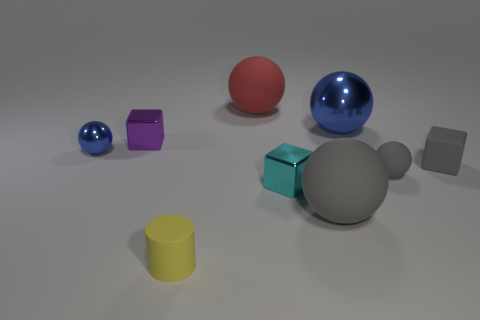What is the size of the blue shiny object that is on the right side of the gray rubber ball to the left of the tiny rubber sphere?
Your response must be concise. Large. What number of cubes are tiny metal objects or big cyan matte objects?
Provide a succinct answer. 2. What is the color of the other matte ball that is the same size as the red sphere?
Offer a very short reply. Gray. There is a gray rubber thing that is to the left of the metallic sphere on the right side of the small yellow object; what is its shape?
Keep it short and to the point. Sphere. There is a shiny thing in front of the matte block; is its size the same as the small blue object?
Provide a succinct answer. Yes. What number of other objects are there of the same material as the red sphere?
Provide a succinct answer. 4. How many gray objects are tiny matte spheres or metallic things?
Offer a terse response. 1. What size is the matte block that is the same color as the small matte sphere?
Provide a short and direct response. Small. How many purple metallic objects are behind the red rubber sphere?
Provide a short and direct response. 0. There is a blue ball left of the thing behind the shiny ball behind the purple cube; what is its size?
Your answer should be very brief. Small. 